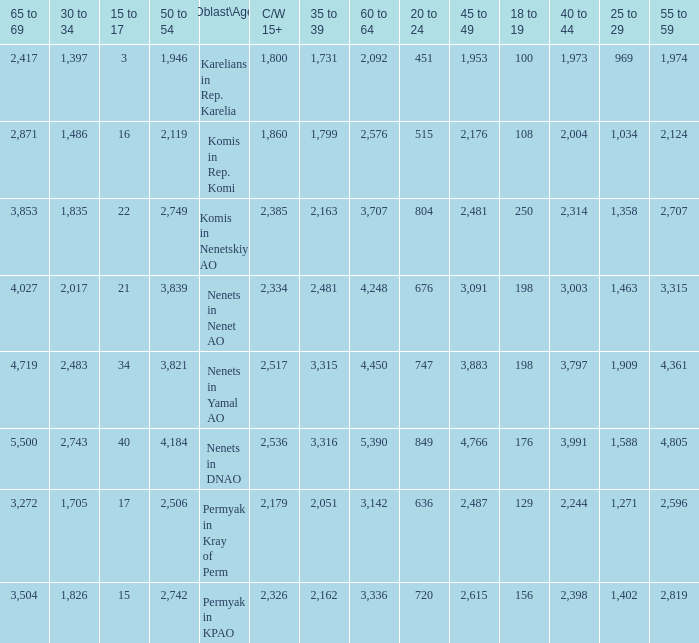What is the number of 40 to 44 when the 50 to 54 is less than 4,184, and the 15 to 17 is less than 3? 0.0. Could you parse the entire table as a dict? {'header': ['65 to 69', '30 to 34', '15 to 17', '50 to 54', 'Oblast\\Age', 'C/W 15+', '35 to 39', '60 to 64', '20 to 24', '45 to 49', '18 to 19', '40 to 44', '25 to 29', '55 to 59'], 'rows': [['2,417', '1,397', '3', '1,946', 'Karelians in Rep. Karelia', '1,800', '1,731', '2,092', '451', '1,953', '100', '1,973', '969', '1,974'], ['2,871', '1,486', '16', '2,119', 'Komis in Rep. Komi', '1,860', '1,799', '2,576', '515', '2,176', '108', '2,004', '1,034', '2,124'], ['3,853', '1,835', '22', '2,749', 'Komis in Nenetskiy AO', '2,385', '2,163', '3,707', '804', '2,481', '250', '2,314', '1,358', '2,707'], ['4,027', '2,017', '21', '3,839', 'Nenets in Nenet AO', '2,334', '2,481', '4,248', '676', '3,091', '198', '3,003', '1,463', '3,315'], ['4,719', '2,483', '34', '3,821', 'Nenets in Yamal AO', '2,517', '3,315', '4,450', '747', '3,883', '198', '3,797', '1,909', '4,361'], ['5,500', '2,743', '40', '4,184', 'Nenets in DNAO', '2,536', '3,316', '5,390', '849', '4,766', '176', '3,991', '1,588', '4,805'], ['3,272', '1,705', '17', '2,506', 'Permyak in Kray of Perm', '2,179', '2,051', '3,142', '636', '2,487', '129', '2,244', '1,271', '2,596'], ['3,504', '1,826', '15', '2,742', 'Permyak in KPAO', '2,326', '2,162', '3,336', '720', '2,615', '156', '2,398', '1,402', '2,819']]} 